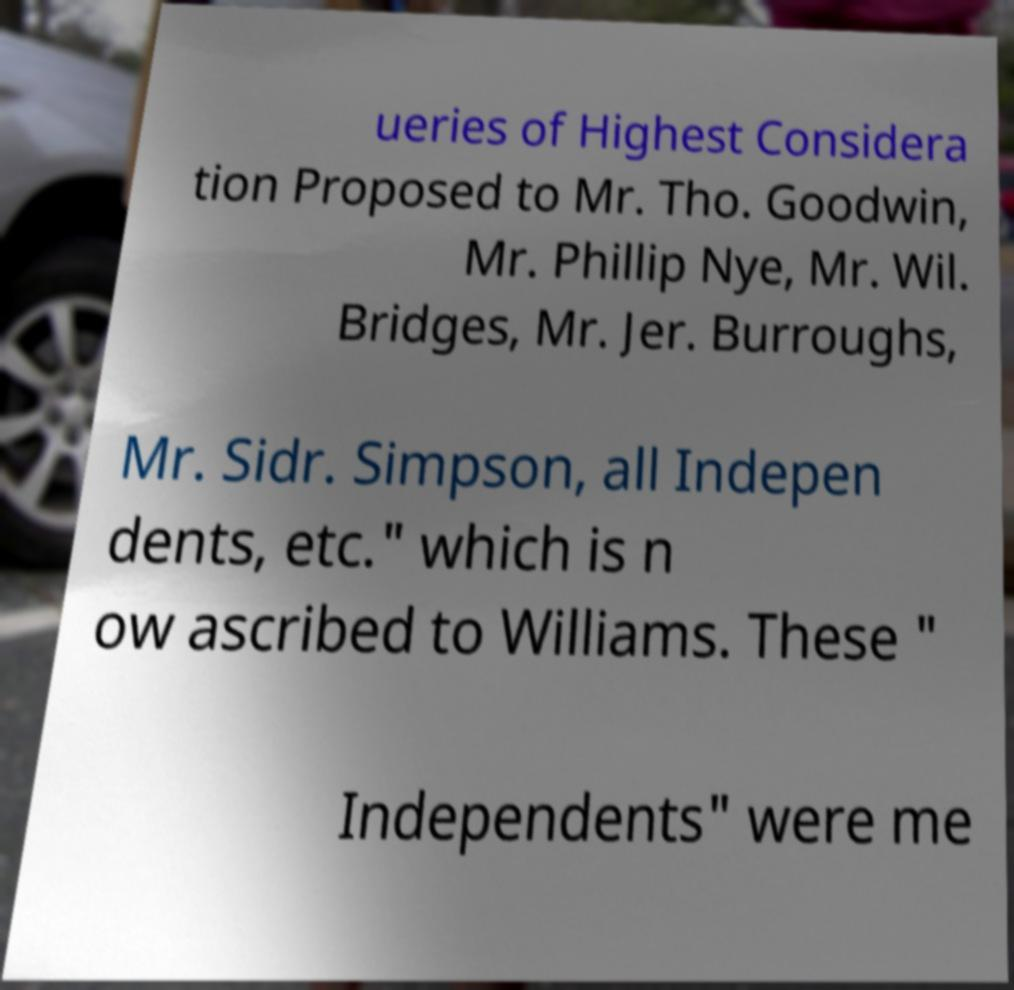Please read and relay the text visible in this image. What does it say? ueries of Highest Considera tion Proposed to Mr. Tho. Goodwin, Mr. Phillip Nye, Mr. Wil. Bridges, Mr. Jer. Burroughs, Mr. Sidr. Simpson, all Indepen dents, etc." which is n ow ascribed to Williams. These " Independents" were me 